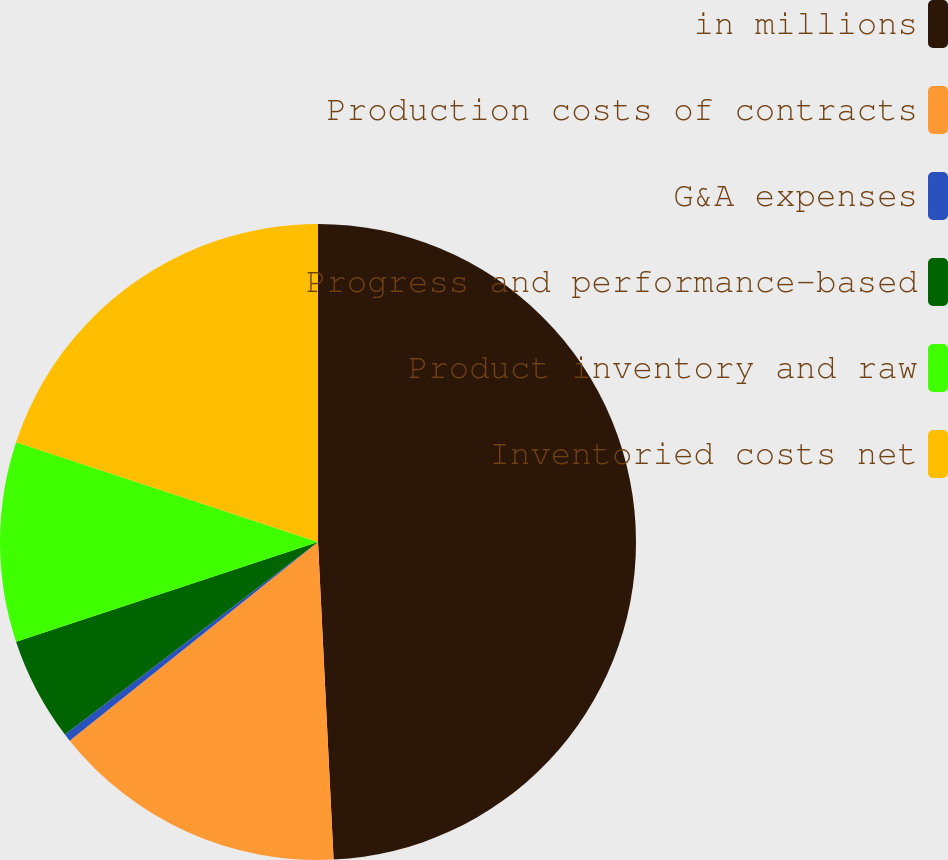Convert chart. <chart><loc_0><loc_0><loc_500><loc_500><pie_chart><fcel>in millions<fcel>Production costs of contracts<fcel>G&A expenses<fcel>Progress and performance-based<fcel>Product inventory and raw<fcel>Inventoried costs net<nl><fcel>49.22%<fcel>15.04%<fcel>0.39%<fcel>5.27%<fcel>10.16%<fcel>19.92%<nl></chart> 